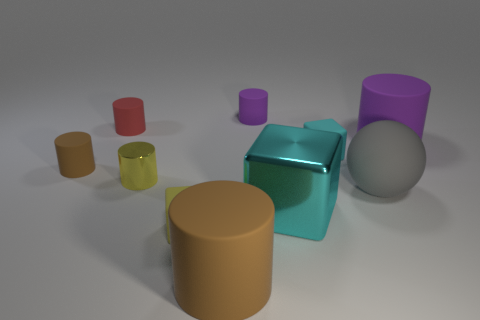Subtract all large cylinders. How many cylinders are left? 4 Subtract all brown cylinders. How many cylinders are left? 4 Subtract all cyan cylinders. Subtract all green blocks. How many cylinders are left? 6 Subtract all spheres. How many objects are left? 9 Subtract 1 yellow cubes. How many objects are left? 9 Subtract all brown matte cylinders. Subtract all tiny yellow metal cylinders. How many objects are left? 7 Add 9 gray matte spheres. How many gray matte spheres are left? 10 Add 6 big purple rubber cylinders. How many big purple rubber cylinders exist? 7 